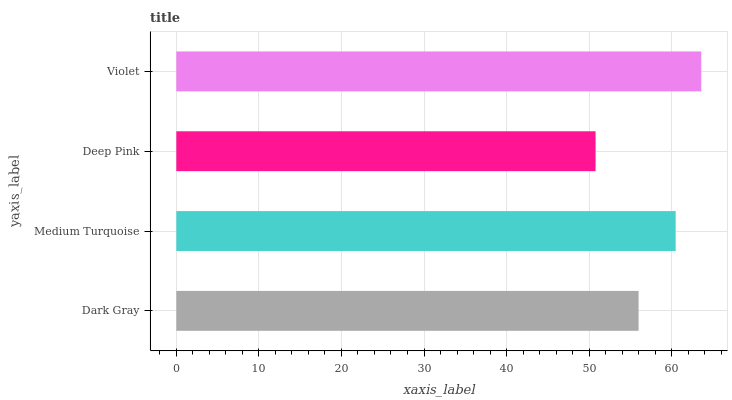Is Deep Pink the minimum?
Answer yes or no. Yes. Is Violet the maximum?
Answer yes or no. Yes. Is Medium Turquoise the minimum?
Answer yes or no. No. Is Medium Turquoise the maximum?
Answer yes or no. No. Is Medium Turquoise greater than Dark Gray?
Answer yes or no. Yes. Is Dark Gray less than Medium Turquoise?
Answer yes or no. Yes. Is Dark Gray greater than Medium Turquoise?
Answer yes or no. No. Is Medium Turquoise less than Dark Gray?
Answer yes or no. No. Is Medium Turquoise the high median?
Answer yes or no. Yes. Is Dark Gray the low median?
Answer yes or no. Yes. Is Violet the high median?
Answer yes or no. No. Is Deep Pink the low median?
Answer yes or no. No. 